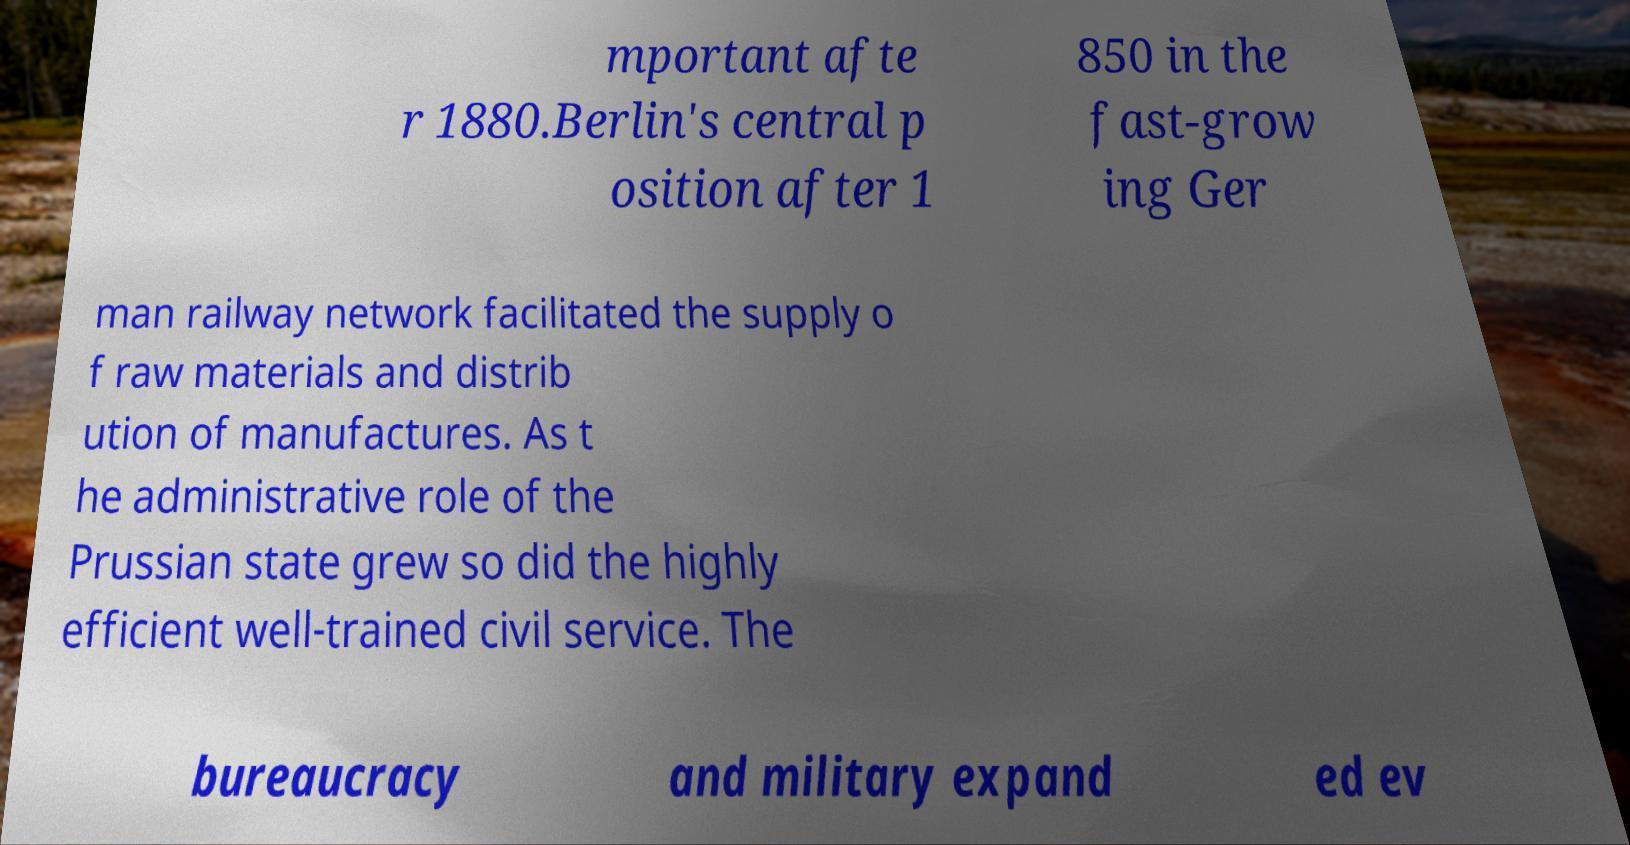What messages or text are displayed in this image? I need them in a readable, typed format. mportant afte r 1880.Berlin's central p osition after 1 850 in the fast-grow ing Ger man railway network facilitated the supply o f raw materials and distrib ution of manufactures. As t he administrative role of the Prussian state grew so did the highly efficient well-trained civil service. The bureaucracy and military expand ed ev 